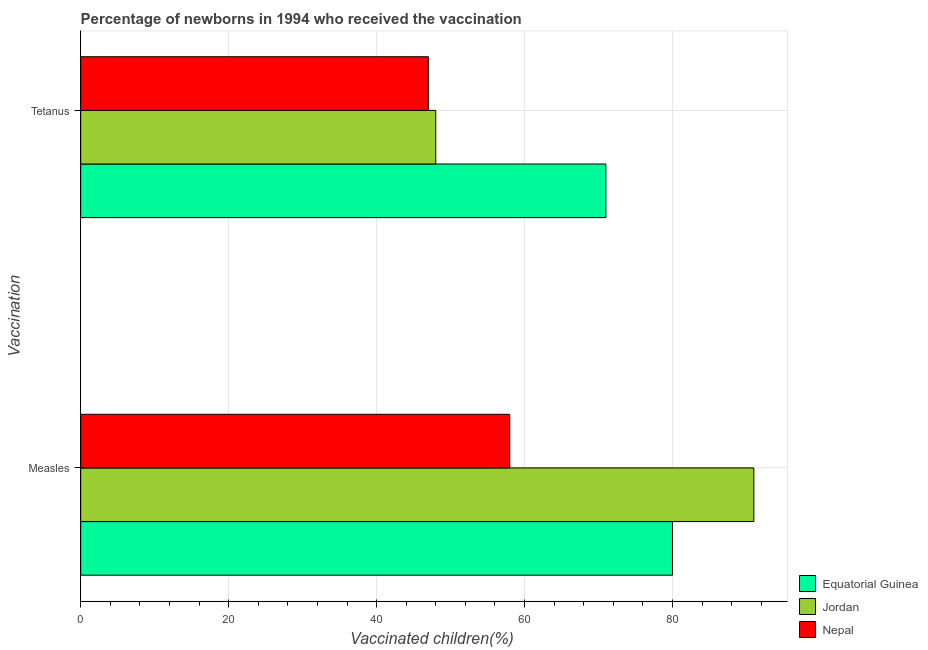How many bars are there on the 2nd tick from the bottom?
Offer a very short reply. 3. What is the label of the 2nd group of bars from the top?
Your answer should be compact. Measles. What is the percentage of newborns who received vaccination for measles in Jordan?
Offer a very short reply. 91. Across all countries, what is the maximum percentage of newborns who received vaccination for measles?
Make the answer very short. 91. Across all countries, what is the minimum percentage of newborns who received vaccination for tetanus?
Provide a succinct answer. 47. In which country was the percentage of newborns who received vaccination for measles maximum?
Your answer should be compact. Jordan. In which country was the percentage of newborns who received vaccination for measles minimum?
Your response must be concise. Nepal. What is the total percentage of newborns who received vaccination for measles in the graph?
Your response must be concise. 229. What is the difference between the percentage of newborns who received vaccination for measles in Nepal and that in Jordan?
Offer a very short reply. -33. What is the difference between the percentage of newborns who received vaccination for measles in Equatorial Guinea and the percentage of newborns who received vaccination for tetanus in Jordan?
Your answer should be very brief. 32. What is the average percentage of newborns who received vaccination for measles per country?
Your answer should be very brief. 76.33. What is the difference between the percentage of newborns who received vaccination for tetanus and percentage of newborns who received vaccination for measles in Equatorial Guinea?
Your response must be concise. -9. What is the ratio of the percentage of newborns who received vaccination for tetanus in Jordan to that in Nepal?
Make the answer very short. 1.02. Is the percentage of newborns who received vaccination for tetanus in Nepal less than that in Equatorial Guinea?
Offer a terse response. Yes. What does the 1st bar from the top in Tetanus represents?
Provide a succinct answer. Nepal. What does the 1st bar from the bottom in Measles represents?
Keep it short and to the point. Equatorial Guinea. How many bars are there?
Make the answer very short. 6. Are all the bars in the graph horizontal?
Provide a short and direct response. Yes. What is the difference between two consecutive major ticks on the X-axis?
Ensure brevity in your answer.  20. How many legend labels are there?
Your response must be concise. 3. How are the legend labels stacked?
Keep it short and to the point. Vertical. What is the title of the graph?
Make the answer very short. Percentage of newborns in 1994 who received the vaccination. Does "Europe(all income levels)" appear as one of the legend labels in the graph?
Give a very brief answer. No. What is the label or title of the X-axis?
Offer a very short reply. Vaccinated children(%)
. What is the label or title of the Y-axis?
Provide a succinct answer. Vaccination. What is the Vaccinated children(%)
 in Jordan in Measles?
Make the answer very short. 91. What is the Vaccinated children(%)
 of Nepal in Measles?
Keep it short and to the point. 58. What is the Vaccinated children(%)
 in Nepal in Tetanus?
Your answer should be compact. 47. Across all Vaccination, what is the maximum Vaccinated children(%)
 in Equatorial Guinea?
Your answer should be very brief. 80. Across all Vaccination, what is the maximum Vaccinated children(%)
 of Jordan?
Make the answer very short. 91. Across all Vaccination, what is the maximum Vaccinated children(%)
 of Nepal?
Offer a very short reply. 58. Across all Vaccination, what is the minimum Vaccinated children(%)
 in Jordan?
Provide a succinct answer. 48. What is the total Vaccinated children(%)
 of Equatorial Guinea in the graph?
Keep it short and to the point. 151. What is the total Vaccinated children(%)
 of Jordan in the graph?
Provide a succinct answer. 139. What is the total Vaccinated children(%)
 in Nepal in the graph?
Provide a short and direct response. 105. What is the difference between the Vaccinated children(%)
 of Jordan in Measles and that in Tetanus?
Provide a short and direct response. 43. What is the difference between the Vaccinated children(%)
 of Nepal in Measles and that in Tetanus?
Your response must be concise. 11. What is the difference between the Vaccinated children(%)
 of Equatorial Guinea in Measles and the Vaccinated children(%)
 of Jordan in Tetanus?
Offer a very short reply. 32. What is the average Vaccinated children(%)
 of Equatorial Guinea per Vaccination?
Your response must be concise. 75.5. What is the average Vaccinated children(%)
 in Jordan per Vaccination?
Offer a terse response. 69.5. What is the average Vaccinated children(%)
 of Nepal per Vaccination?
Ensure brevity in your answer.  52.5. What is the difference between the Vaccinated children(%)
 in Equatorial Guinea and Vaccinated children(%)
 in Jordan in Measles?
Offer a terse response. -11. What is the difference between the Vaccinated children(%)
 of Equatorial Guinea and Vaccinated children(%)
 of Nepal in Measles?
Offer a terse response. 22. What is the difference between the Vaccinated children(%)
 of Equatorial Guinea and Vaccinated children(%)
 of Nepal in Tetanus?
Make the answer very short. 24. What is the difference between the Vaccinated children(%)
 in Jordan and Vaccinated children(%)
 in Nepal in Tetanus?
Keep it short and to the point. 1. What is the ratio of the Vaccinated children(%)
 in Equatorial Guinea in Measles to that in Tetanus?
Ensure brevity in your answer.  1.13. What is the ratio of the Vaccinated children(%)
 of Jordan in Measles to that in Tetanus?
Give a very brief answer. 1.9. What is the ratio of the Vaccinated children(%)
 of Nepal in Measles to that in Tetanus?
Offer a very short reply. 1.23. What is the difference between the highest and the second highest Vaccinated children(%)
 in Jordan?
Ensure brevity in your answer.  43. What is the difference between the highest and the lowest Vaccinated children(%)
 of Jordan?
Provide a short and direct response. 43. 